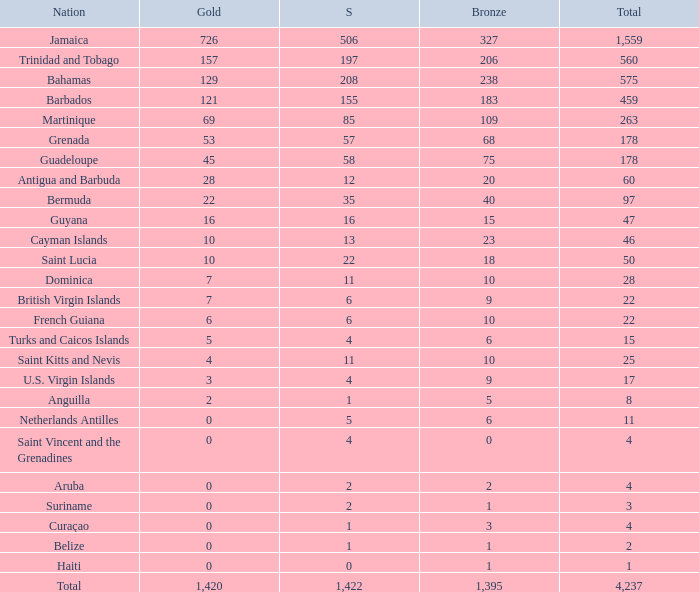What's the sum of Silver with total smaller than 560, a Bronze larger than 6, and a Gold of 3? 4.0. 